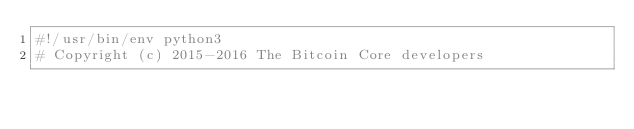Convert code to text. <code><loc_0><loc_0><loc_500><loc_500><_Python_>#!/usr/bin/env python3
# Copyright (c) 2015-2016 The Bitcoin Core developers</code> 